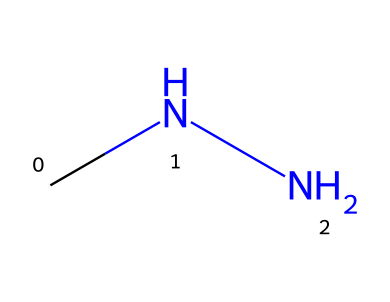What is the molecular formula of methylhydrazine? The SMILES representation "CNN" indicates that there are two nitrogen atoms (N) and four hydrogen atoms (H) along with one carbon atom (C), leading to the molecular formula C2H8N2.
Answer: C2H8N2 How many hydrogen atoms are present in methylhydrazine? From the SMILES notation "CNN", it is clear that there are eight hydrogen atoms connected to the carbon and nitrogen atoms.
Answer: 8 What type of bonding is primarily present in methylhydrazine? The structure contains single bonds between the carbon and nitrogen atoms as well as between the nitrogen and hydrogen atoms, indicating that covalent bonding is the primary type of bonding in this molecule.
Answer: covalent What potential application does methylhydrazine have in relation to metals? Methylhydrazine functions as a corrosion inhibitor for metal structures, helping to protect them from degradation caused by environmental factors.
Answer: corrosion inhibitor Which atoms in methylhydrazine contribute to its reactivity with metal surfaces? The nitrogen atoms in methylhydrazine are particularly reactive and can interact with metal surfaces to form protective layers, enhancing its suitability as a corrosion inhibitor.
Answer: nitrogen Why is the molecular arrangement of methylhydrazine important for its use in corrosion management? The arrangement allows for effective interaction with metal surfaces, as the two nitrogen atoms can coordinate with metals, which stabilizes the metal and prevents corrosion.
Answer: effective interaction 